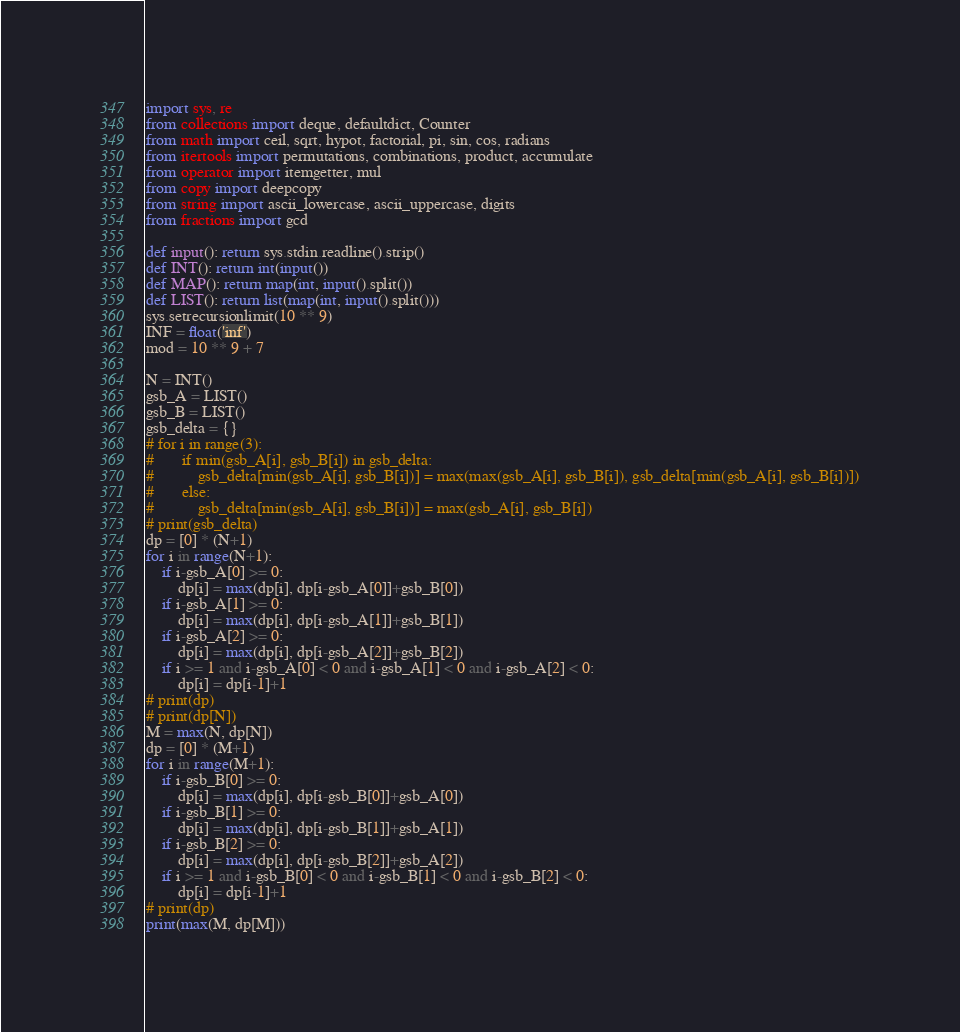Convert code to text. <code><loc_0><loc_0><loc_500><loc_500><_Python_>import sys, re
from collections import deque, defaultdict, Counter
from math import ceil, sqrt, hypot, factorial, pi, sin, cos, radians
from itertools import permutations, combinations, product, accumulate
from operator import itemgetter, mul
from copy import deepcopy
from string import ascii_lowercase, ascii_uppercase, digits
from fractions import gcd

def input(): return sys.stdin.readline().strip()
def INT(): return int(input())
def MAP(): return map(int, input().split())
def LIST(): return list(map(int, input().split()))
sys.setrecursionlimit(10 ** 9)
INF = float('inf')
mod = 10 ** 9 + 7

N = INT()
gsb_A = LIST()
gsb_B = LIST()
gsb_delta = {}
# for i in range(3):
# 		if min(gsb_A[i], gsb_B[i]) in gsb_delta:
# 			gsb_delta[min(gsb_A[i], gsb_B[i])] = max(max(gsb_A[i], gsb_B[i]), gsb_delta[min(gsb_A[i], gsb_B[i])])
# 		else:
# 			gsb_delta[min(gsb_A[i], gsb_B[i])] = max(gsb_A[i], gsb_B[i])
# print(gsb_delta)
dp = [0] * (N+1)
for i in range(N+1):
	if i-gsb_A[0] >= 0:
		dp[i] = max(dp[i], dp[i-gsb_A[0]]+gsb_B[0])
	if i-gsb_A[1] >= 0:
		dp[i] = max(dp[i], dp[i-gsb_A[1]]+gsb_B[1])
	if i-gsb_A[2] >= 0:
		dp[i] = max(dp[i], dp[i-gsb_A[2]]+gsb_B[2])
	if i >= 1 and i-gsb_A[0] < 0 and i-gsb_A[1] < 0 and i-gsb_A[2] < 0:
		dp[i] = dp[i-1]+1
# print(dp)
# print(dp[N])
M = max(N, dp[N])
dp = [0] * (M+1)
for i in range(M+1):
	if i-gsb_B[0] >= 0:
		dp[i] = max(dp[i], dp[i-gsb_B[0]]+gsb_A[0])
	if i-gsb_B[1] >= 0:
		dp[i] = max(dp[i], dp[i-gsb_B[1]]+gsb_A[1])
	if i-gsb_B[2] >= 0:
		dp[i] = max(dp[i], dp[i-gsb_B[2]]+gsb_A[2])
	if i >= 1 and i-gsb_B[0] < 0 and i-gsb_B[1] < 0 and i-gsb_B[2] < 0:
		dp[i] = dp[i-1]+1
# print(dp)
print(max(M, dp[M]))
</code> 